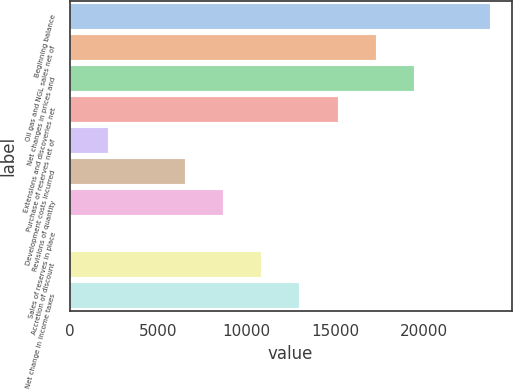Convert chart to OTSL. <chart><loc_0><loc_0><loc_500><loc_500><bar_chart><fcel>Beginning balance<fcel>Oil gas and NGL sales net of<fcel>Net changes in prices and<fcel>Extensions and discoveries net<fcel>Purchase of reserves net of<fcel>Development costs incurred<fcel>Revisions of quantity<fcel>Sales of reserves in place<fcel>Accretion of discount<fcel>Net change in income taxes<nl><fcel>23790.9<fcel>17305.2<fcel>19467.1<fcel>15143.3<fcel>2171.9<fcel>6495.7<fcel>8657.6<fcel>10<fcel>10819.5<fcel>12981.4<nl></chart> 